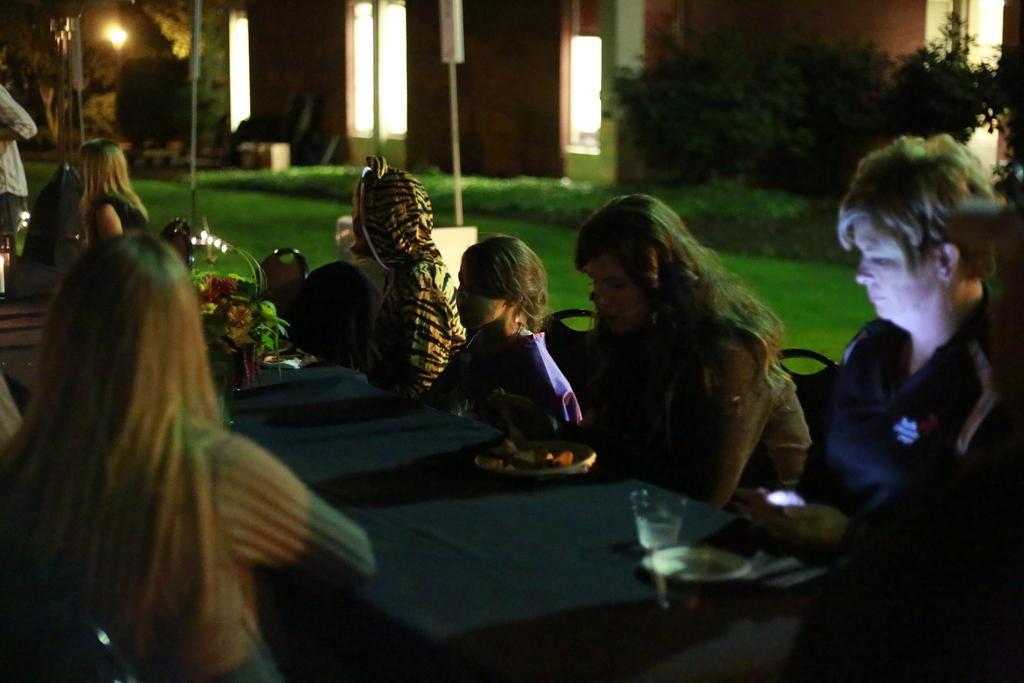In one or two sentences, can you explain what this image depicts? This persons are sitting on a chair. In-front of this person there is a table, on a table there are plates and glasses. Far there is a light in between of this trees. This is a building. Beside this grass there are plants. 